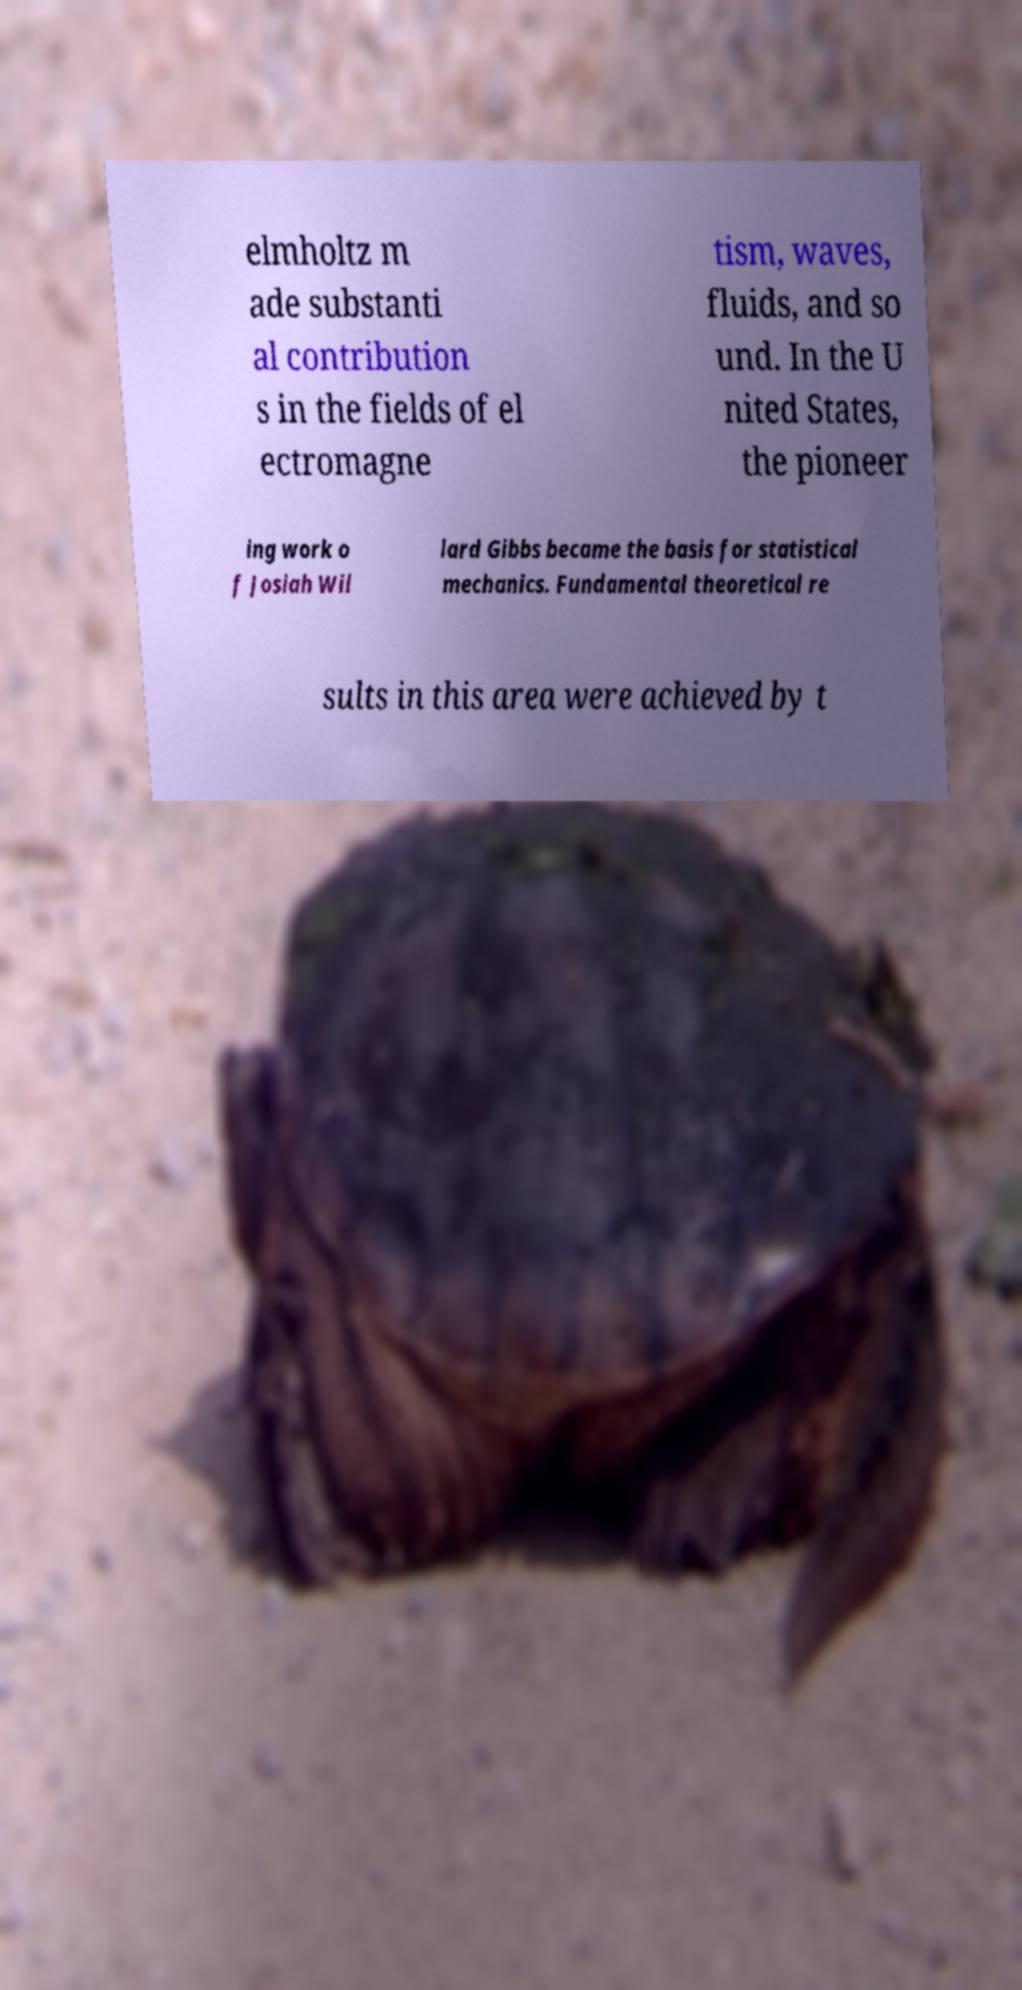Please read and relay the text visible in this image. What does it say? elmholtz m ade substanti al contribution s in the fields of el ectromagne tism, waves, fluids, and so und. In the U nited States, the pioneer ing work o f Josiah Wil lard Gibbs became the basis for statistical mechanics. Fundamental theoretical re sults in this area were achieved by t 